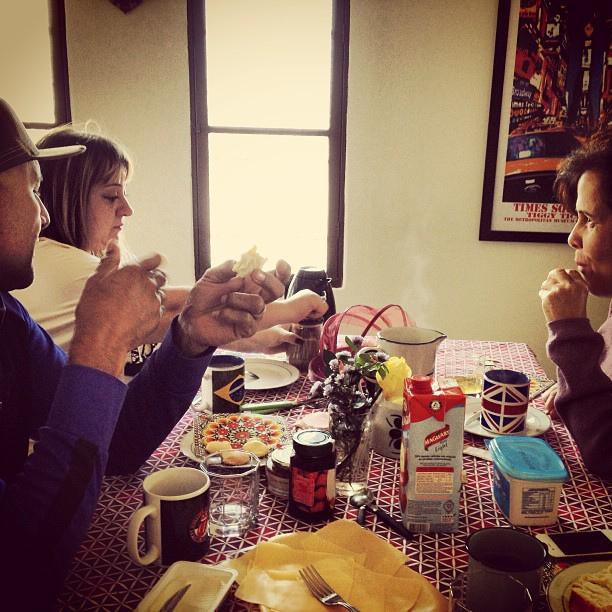Are these people young?
Short answer required. No. What number of people are around the table?
Keep it brief. 3. Was this meal home cooked?
Short answer required. Yes. Is the window open?
Quick response, please. No. How much coffee is present?
Quick response, please. 3. How many people?
Give a very brief answer. 3. Are there drinks on the table?
Quick response, please. Yes. What type of food is inside the boxes?
Keep it brief. Milk and tea. How many of the people are female?
Give a very brief answer. 1. Is a flat screen TV in the room?
Write a very short answer. No. 